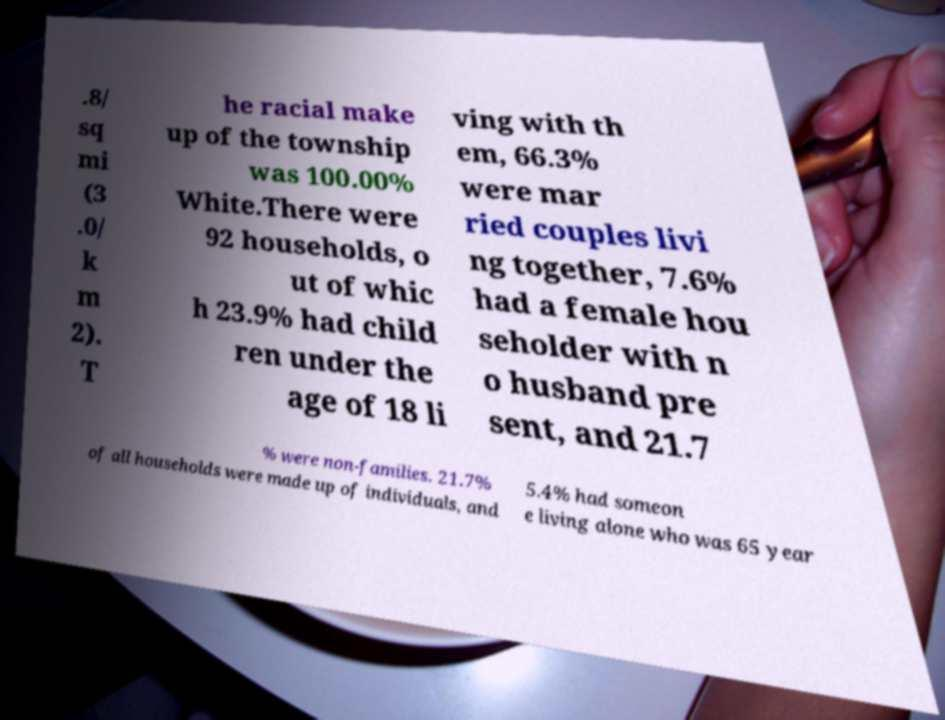What messages or text are displayed in this image? I need them in a readable, typed format. .8/ sq mi (3 .0/ k m 2). T he racial make up of the township was 100.00% White.There were 92 households, o ut of whic h 23.9% had child ren under the age of 18 li ving with th em, 66.3% were mar ried couples livi ng together, 7.6% had a female hou seholder with n o husband pre sent, and 21.7 % were non-families. 21.7% of all households were made up of individuals, and 5.4% had someon e living alone who was 65 year 